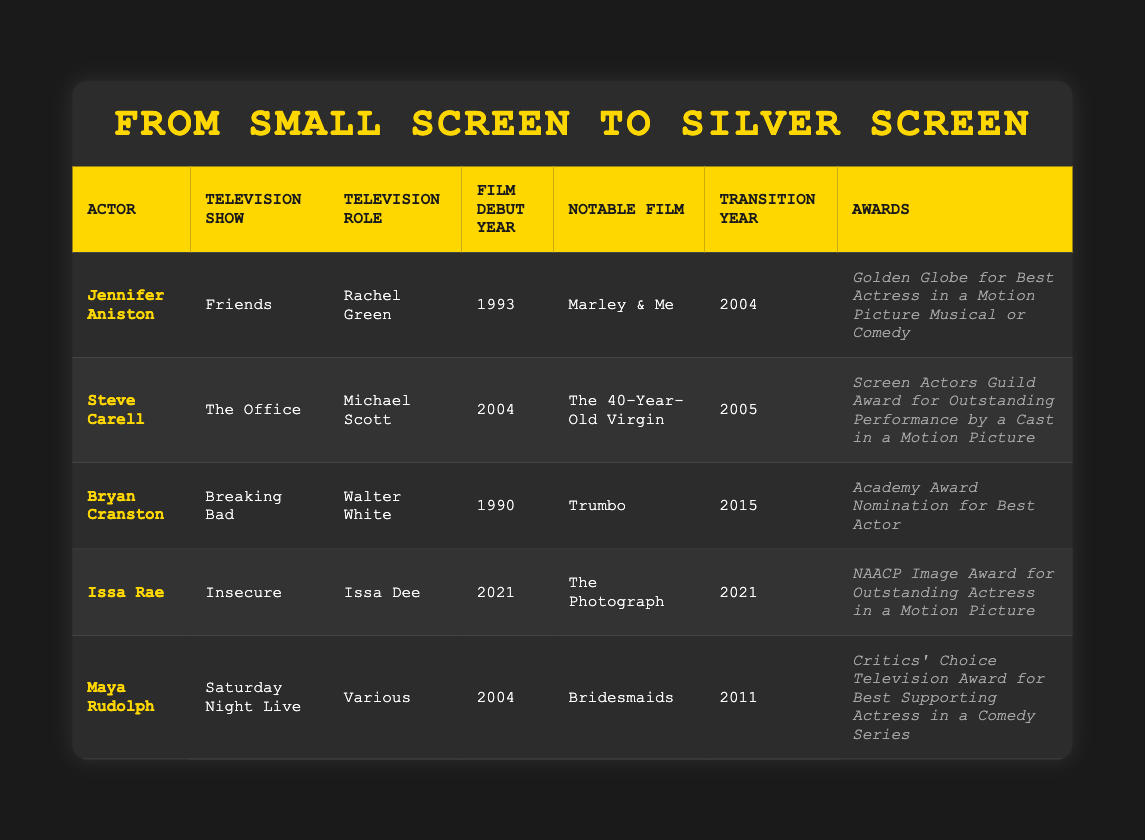What notable film did Jennifer Aniston star in after her television role? Jennifer Aniston's notable film listed is "Marley & Me," which is found in the table under the column "Notable Film."
Answer: Marley & Me Which actor made their film debut in 2021? The table shows that Issa Rae made her film debut in 2021, denoted in the column "Film Debut Year."
Answer: Issa Rae What year did Steve Carell transition from television to film? According to the table, Steve Carell's transition year is marked as 2005 in the "Transition Year" column.
Answer: 2005 Did Bryan Cranston receive an award for his transition to film? The table indicates that Bryan Cranston received an Academy Award nomination for Best Actor, confirming that he did receive an award for his performance in film.
Answer: Yes Who had their film debut earlier: Maya Rudolph or Jennifer Aniston? By comparing the "Film Debut Year" columns, we see that Jennifer Aniston debuted in 1993, while Maya Rudolph debuted in 2004. Therefore, Aniston's debut was earlier.
Answer: Jennifer Aniston What is the difference in transition years between Steve Carell and Issa Rae? Steve Carell's transition year is 2005, and Issa Rae's is 2021. To find the difference, subtract 2005 from 2021, which is 16 years.
Answer: 16 years Which actor received a Golden Globe award after transitioning to film? The table states that Jennifer Aniston received the Golden Globe for Best Actress in a Motion Picture Musical or Comedy, confirming her award after transitioning to film.
Answer: Yes What is the average film debut year of the actors listed? The film debut years are 1993 (Aniston), 2004 (Carell), 1990 (Cranston), 2021 (Rae), 2004 (Rudolph). Adding these years gives 1993 + 2004 + 1990 + 2021 + 2004 = 10012. Dividing this by 5 (the number of actors) gives an average of 2002.4, which rounds to 2002.
Answer: 2002 What was the television role of Maya Rudolph? The table indicates that Maya Rudolph's television role was "Various," which is stated under the "Television Role" column.
Answer: Various 